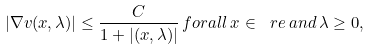Convert formula to latex. <formula><loc_0><loc_0><loc_500><loc_500>| \nabla v ( x , \lambda ) | \leq \frac { C } { 1 + | ( x , \lambda ) | } \, f o r a l l \, x \in \ r e \, a n d \, \lambda \geq 0 ,</formula> 